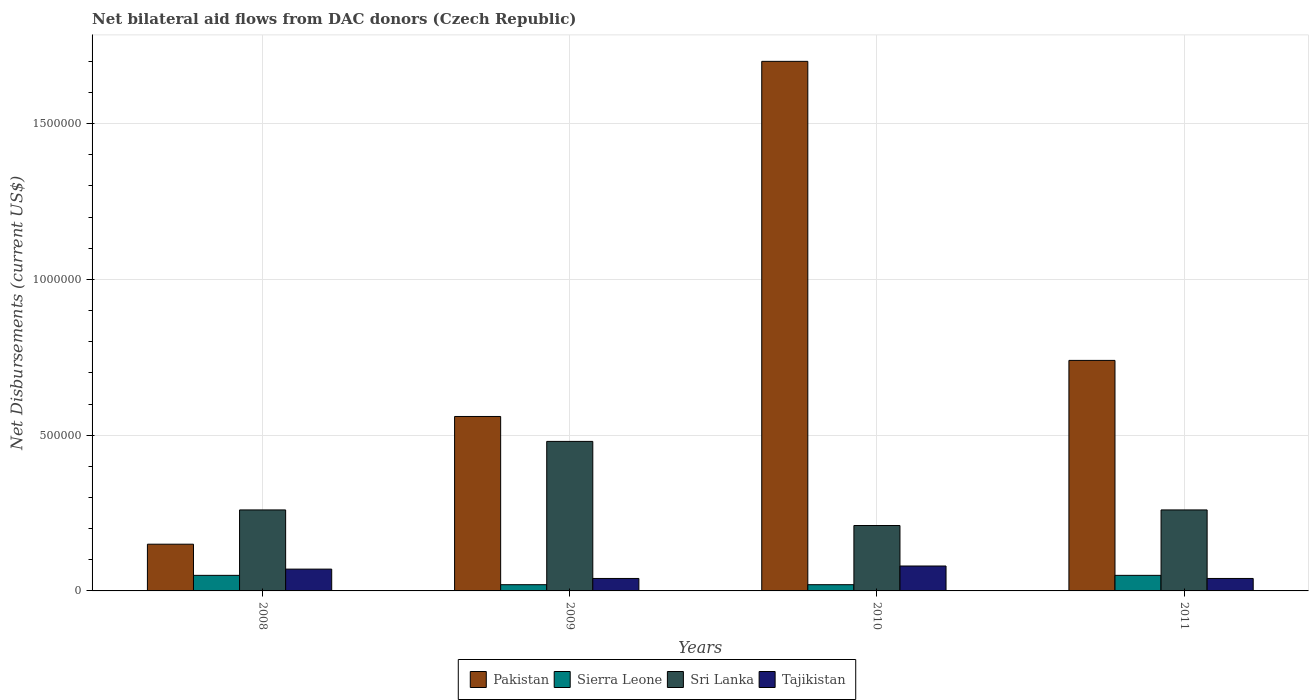How many groups of bars are there?
Keep it short and to the point. 4. Are the number of bars on each tick of the X-axis equal?
Keep it short and to the point. Yes. How many bars are there on the 3rd tick from the left?
Offer a very short reply. 4. What is the label of the 1st group of bars from the left?
Offer a very short reply. 2008. In how many cases, is the number of bars for a given year not equal to the number of legend labels?
Make the answer very short. 0. What is the net bilateral aid flows in Sri Lanka in 2010?
Keep it short and to the point. 2.10e+05. Across all years, what is the maximum net bilateral aid flows in Tajikistan?
Give a very brief answer. 8.00e+04. Across all years, what is the minimum net bilateral aid flows in Sri Lanka?
Provide a short and direct response. 2.10e+05. What is the total net bilateral aid flows in Sierra Leone in the graph?
Provide a succinct answer. 1.40e+05. What is the difference between the net bilateral aid flows in Sri Lanka in 2008 and that in 2010?
Offer a very short reply. 5.00e+04. What is the difference between the net bilateral aid flows in Tajikistan in 2008 and the net bilateral aid flows in Pakistan in 2011?
Your response must be concise. -6.70e+05. What is the average net bilateral aid flows in Tajikistan per year?
Make the answer very short. 5.75e+04. In the year 2008, what is the difference between the net bilateral aid flows in Tajikistan and net bilateral aid flows in Sri Lanka?
Your answer should be very brief. -1.90e+05. In how many years, is the net bilateral aid flows in Pakistan greater than 1400000 US$?
Provide a succinct answer. 1. What is the ratio of the net bilateral aid flows in Pakistan in 2009 to that in 2011?
Your answer should be compact. 0.76. Is the difference between the net bilateral aid flows in Tajikistan in 2008 and 2011 greater than the difference between the net bilateral aid flows in Sri Lanka in 2008 and 2011?
Your answer should be compact. Yes. What is the difference between the highest and the second highest net bilateral aid flows in Sierra Leone?
Provide a succinct answer. 0. What is the difference between the highest and the lowest net bilateral aid flows in Sri Lanka?
Your response must be concise. 2.70e+05. Is it the case that in every year, the sum of the net bilateral aid flows in Sierra Leone and net bilateral aid flows in Sri Lanka is greater than the sum of net bilateral aid flows in Tajikistan and net bilateral aid flows in Pakistan?
Provide a succinct answer. No. What does the 3rd bar from the left in 2010 represents?
Make the answer very short. Sri Lanka. What does the 3rd bar from the right in 2009 represents?
Your answer should be compact. Sierra Leone. How many bars are there?
Your answer should be very brief. 16. Does the graph contain any zero values?
Provide a succinct answer. No. Does the graph contain grids?
Provide a succinct answer. Yes. Where does the legend appear in the graph?
Provide a short and direct response. Bottom center. How are the legend labels stacked?
Make the answer very short. Horizontal. What is the title of the graph?
Offer a terse response. Net bilateral aid flows from DAC donors (Czech Republic). What is the label or title of the Y-axis?
Provide a short and direct response. Net Disbursements (current US$). What is the Net Disbursements (current US$) of Pakistan in 2008?
Make the answer very short. 1.50e+05. What is the Net Disbursements (current US$) of Tajikistan in 2008?
Your answer should be very brief. 7.00e+04. What is the Net Disbursements (current US$) of Pakistan in 2009?
Offer a very short reply. 5.60e+05. What is the Net Disbursements (current US$) of Sierra Leone in 2009?
Your answer should be very brief. 2.00e+04. What is the Net Disbursements (current US$) of Tajikistan in 2009?
Your response must be concise. 4.00e+04. What is the Net Disbursements (current US$) in Pakistan in 2010?
Your answer should be compact. 1.70e+06. What is the Net Disbursements (current US$) in Sierra Leone in 2010?
Your answer should be very brief. 2.00e+04. What is the Net Disbursements (current US$) of Sri Lanka in 2010?
Offer a terse response. 2.10e+05. What is the Net Disbursements (current US$) of Tajikistan in 2010?
Your answer should be compact. 8.00e+04. What is the Net Disbursements (current US$) of Pakistan in 2011?
Offer a very short reply. 7.40e+05. What is the Net Disbursements (current US$) in Sierra Leone in 2011?
Offer a terse response. 5.00e+04. Across all years, what is the maximum Net Disbursements (current US$) in Pakistan?
Make the answer very short. 1.70e+06. Across all years, what is the maximum Net Disbursements (current US$) of Sierra Leone?
Give a very brief answer. 5.00e+04. Across all years, what is the maximum Net Disbursements (current US$) in Sri Lanka?
Provide a short and direct response. 4.80e+05. Across all years, what is the minimum Net Disbursements (current US$) of Pakistan?
Offer a very short reply. 1.50e+05. What is the total Net Disbursements (current US$) in Pakistan in the graph?
Ensure brevity in your answer.  3.15e+06. What is the total Net Disbursements (current US$) in Sri Lanka in the graph?
Your answer should be very brief. 1.21e+06. What is the difference between the Net Disbursements (current US$) of Pakistan in 2008 and that in 2009?
Make the answer very short. -4.10e+05. What is the difference between the Net Disbursements (current US$) of Sierra Leone in 2008 and that in 2009?
Give a very brief answer. 3.00e+04. What is the difference between the Net Disbursements (current US$) in Tajikistan in 2008 and that in 2009?
Your answer should be compact. 3.00e+04. What is the difference between the Net Disbursements (current US$) in Pakistan in 2008 and that in 2010?
Keep it short and to the point. -1.55e+06. What is the difference between the Net Disbursements (current US$) in Sri Lanka in 2008 and that in 2010?
Offer a terse response. 5.00e+04. What is the difference between the Net Disbursements (current US$) of Pakistan in 2008 and that in 2011?
Provide a succinct answer. -5.90e+05. What is the difference between the Net Disbursements (current US$) in Sierra Leone in 2008 and that in 2011?
Offer a terse response. 0. What is the difference between the Net Disbursements (current US$) in Sri Lanka in 2008 and that in 2011?
Give a very brief answer. 0. What is the difference between the Net Disbursements (current US$) of Pakistan in 2009 and that in 2010?
Provide a short and direct response. -1.14e+06. What is the difference between the Net Disbursements (current US$) of Tajikistan in 2009 and that in 2011?
Make the answer very short. 0. What is the difference between the Net Disbursements (current US$) of Pakistan in 2010 and that in 2011?
Provide a succinct answer. 9.60e+05. What is the difference between the Net Disbursements (current US$) in Sierra Leone in 2010 and that in 2011?
Make the answer very short. -3.00e+04. What is the difference between the Net Disbursements (current US$) of Pakistan in 2008 and the Net Disbursements (current US$) of Sri Lanka in 2009?
Offer a very short reply. -3.30e+05. What is the difference between the Net Disbursements (current US$) in Sierra Leone in 2008 and the Net Disbursements (current US$) in Sri Lanka in 2009?
Make the answer very short. -4.30e+05. What is the difference between the Net Disbursements (current US$) of Sri Lanka in 2008 and the Net Disbursements (current US$) of Tajikistan in 2009?
Your answer should be very brief. 2.20e+05. What is the difference between the Net Disbursements (current US$) in Sierra Leone in 2008 and the Net Disbursements (current US$) in Sri Lanka in 2010?
Keep it short and to the point. -1.60e+05. What is the difference between the Net Disbursements (current US$) in Sierra Leone in 2008 and the Net Disbursements (current US$) in Tajikistan in 2010?
Your answer should be very brief. -3.00e+04. What is the difference between the Net Disbursements (current US$) of Pakistan in 2008 and the Net Disbursements (current US$) of Sri Lanka in 2011?
Keep it short and to the point. -1.10e+05. What is the difference between the Net Disbursements (current US$) in Sierra Leone in 2008 and the Net Disbursements (current US$) in Sri Lanka in 2011?
Offer a terse response. -2.10e+05. What is the difference between the Net Disbursements (current US$) of Pakistan in 2009 and the Net Disbursements (current US$) of Sierra Leone in 2010?
Give a very brief answer. 5.40e+05. What is the difference between the Net Disbursements (current US$) of Sierra Leone in 2009 and the Net Disbursements (current US$) of Sri Lanka in 2010?
Your response must be concise. -1.90e+05. What is the difference between the Net Disbursements (current US$) in Sierra Leone in 2009 and the Net Disbursements (current US$) in Tajikistan in 2010?
Provide a short and direct response. -6.00e+04. What is the difference between the Net Disbursements (current US$) of Pakistan in 2009 and the Net Disbursements (current US$) of Sierra Leone in 2011?
Give a very brief answer. 5.10e+05. What is the difference between the Net Disbursements (current US$) of Pakistan in 2009 and the Net Disbursements (current US$) of Tajikistan in 2011?
Your answer should be compact. 5.20e+05. What is the difference between the Net Disbursements (current US$) of Sierra Leone in 2009 and the Net Disbursements (current US$) of Sri Lanka in 2011?
Ensure brevity in your answer.  -2.40e+05. What is the difference between the Net Disbursements (current US$) in Pakistan in 2010 and the Net Disbursements (current US$) in Sierra Leone in 2011?
Provide a succinct answer. 1.65e+06. What is the difference between the Net Disbursements (current US$) of Pakistan in 2010 and the Net Disbursements (current US$) of Sri Lanka in 2011?
Ensure brevity in your answer.  1.44e+06. What is the difference between the Net Disbursements (current US$) of Pakistan in 2010 and the Net Disbursements (current US$) of Tajikistan in 2011?
Your answer should be very brief. 1.66e+06. What is the difference between the Net Disbursements (current US$) in Sierra Leone in 2010 and the Net Disbursements (current US$) in Sri Lanka in 2011?
Offer a very short reply. -2.40e+05. What is the difference between the Net Disbursements (current US$) of Sierra Leone in 2010 and the Net Disbursements (current US$) of Tajikistan in 2011?
Give a very brief answer. -2.00e+04. What is the difference between the Net Disbursements (current US$) of Sri Lanka in 2010 and the Net Disbursements (current US$) of Tajikistan in 2011?
Offer a very short reply. 1.70e+05. What is the average Net Disbursements (current US$) in Pakistan per year?
Give a very brief answer. 7.88e+05. What is the average Net Disbursements (current US$) of Sierra Leone per year?
Your answer should be very brief. 3.50e+04. What is the average Net Disbursements (current US$) of Sri Lanka per year?
Keep it short and to the point. 3.02e+05. What is the average Net Disbursements (current US$) of Tajikistan per year?
Your answer should be compact. 5.75e+04. In the year 2008, what is the difference between the Net Disbursements (current US$) of Pakistan and Net Disbursements (current US$) of Sierra Leone?
Your answer should be very brief. 1.00e+05. In the year 2008, what is the difference between the Net Disbursements (current US$) of Sierra Leone and Net Disbursements (current US$) of Sri Lanka?
Offer a very short reply. -2.10e+05. In the year 2008, what is the difference between the Net Disbursements (current US$) of Sierra Leone and Net Disbursements (current US$) of Tajikistan?
Give a very brief answer. -2.00e+04. In the year 2009, what is the difference between the Net Disbursements (current US$) of Pakistan and Net Disbursements (current US$) of Sierra Leone?
Give a very brief answer. 5.40e+05. In the year 2009, what is the difference between the Net Disbursements (current US$) in Pakistan and Net Disbursements (current US$) in Tajikistan?
Provide a short and direct response. 5.20e+05. In the year 2009, what is the difference between the Net Disbursements (current US$) of Sierra Leone and Net Disbursements (current US$) of Sri Lanka?
Give a very brief answer. -4.60e+05. In the year 2009, what is the difference between the Net Disbursements (current US$) in Sierra Leone and Net Disbursements (current US$) in Tajikistan?
Provide a short and direct response. -2.00e+04. In the year 2010, what is the difference between the Net Disbursements (current US$) of Pakistan and Net Disbursements (current US$) of Sierra Leone?
Make the answer very short. 1.68e+06. In the year 2010, what is the difference between the Net Disbursements (current US$) of Pakistan and Net Disbursements (current US$) of Sri Lanka?
Offer a very short reply. 1.49e+06. In the year 2010, what is the difference between the Net Disbursements (current US$) of Pakistan and Net Disbursements (current US$) of Tajikistan?
Provide a short and direct response. 1.62e+06. In the year 2010, what is the difference between the Net Disbursements (current US$) in Sierra Leone and Net Disbursements (current US$) in Tajikistan?
Make the answer very short. -6.00e+04. In the year 2010, what is the difference between the Net Disbursements (current US$) in Sri Lanka and Net Disbursements (current US$) in Tajikistan?
Your answer should be compact. 1.30e+05. In the year 2011, what is the difference between the Net Disbursements (current US$) of Pakistan and Net Disbursements (current US$) of Sierra Leone?
Make the answer very short. 6.90e+05. In the year 2011, what is the difference between the Net Disbursements (current US$) in Pakistan and Net Disbursements (current US$) in Sri Lanka?
Keep it short and to the point. 4.80e+05. In the year 2011, what is the difference between the Net Disbursements (current US$) in Sri Lanka and Net Disbursements (current US$) in Tajikistan?
Give a very brief answer. 2.20e+05. What is the ratio of the Net Disbursements (current US$) in Pakistan in 2008 to that in 2009?
Keep it short and to the point. 0.27. What is the ratio of the Net Disbursements (current US$) in Sierra Leone in 2008 to that in 2009?
Provide a short and direct response. 2.5. What is the ratio of the Net Disbursements (current US$) of Sri Lanka in 2008 to that in 2009?
Your answer should be compact. 0.54. What is the ratio of the Net Disbursements (current US$) in Tajikistan in 2008 to that in 2009?
Keep it short and to the point. 1.75. What is the ratio of the Net Disbursements (current US$) of Pakistan in 2008 to that in 2010?
Provide a succinct answer. 0.09. What is the ratio of the Net Disbursements (current US$) of Sri Lanka in 2008 to that in 2010?
Offer a very short reply. 1.24. What is the ratio of the Net Disbursements (current US$) of Tajikistan in 2008 to that in 2010?
Your answer should be very brief. 0.88. What is the ratio of the Net Disbursements (current US$) in Pakistan in 2008 to that in 2011?
Keep it short and to the point. 0.2. What is the ratio of the Net Disbursements (current US$) of Sierra Leone in 2008 to that in 2011?
Offer a terse response. 1. What is the ratio of the Net Disbursements (current US$) in Sri Lanka in 2008 to that in 2011?
Provide a succinct answer. 1. What is the ratio of the Net Disbursements (current US$) of Tajikistan in 2008 to that in 2011?
Your answer should be compact. 1.75. What is the ratio of the Net Disbursements (current US$) of Pakistan in 2009 to that in 2010?
Offer a very short reply. 0.33. What is the ratio of the Net Disbursements (current US$) of Sierra Leone in 2009 to that in 2010?
Provide a short and direct response. 1. What is the ratio of the Net Disbursements (current US$) of Sri Lanka in 2009 to that in 2010?
Offer a very short reply. 2.29. What is the ratio of the Net Disbursements (current US$) of Tajikistan in 2009 to that in 2010?
Offer a terse response. 0.5. What is the ratio of the Net Disbursements (current US$) in Pakistan in 2009 to that in 2011?
Your response must be concise. 0.76. What is the ratio of the Net Disbursements (current US$) in Sierra Leone in 2009 to that in 2011?
Provide a short and direct response. 0.4. What is the ratio of the Net Disbursements (current US$) in Sri Lanka in 2009 to that in 2011?
Your response must be concise. 1.85. What is the ratio of the Net Disbursements (current US$) in Pakistan in 2010 to that in 2011?
Your response must be concise. 2.3. What is the ratio of the Net Disbursements (current US$) in Sierra Leone in 2010 to that in 2011?
Offer a very short reply. 0.4. What is the ratio of the Net Disbursements (current US$) of Sri Lanka in 2010 to that in 2011?
Give a very brief answer. 0.81. What is the difference between the highest and the second highest Net Disbursements (current US$) in Pakistan?
Ensure brevity in your answer.  9.60e+05. What is the difference between the highest and the lowest Net Disbursements (current US$) in Pakistan?
Ensure brevity in your answer.  1.55e+06. What is the difference between the highest and the lowest Net Disbursements (current US$) of Sri Lanka?
Keep it short and to the point. 2.70e+05. What is the difference between the highest and the lowest Net Disbursements (current US$) in Tajikistan?
Your answer should be very brief. 4.00e+04. 